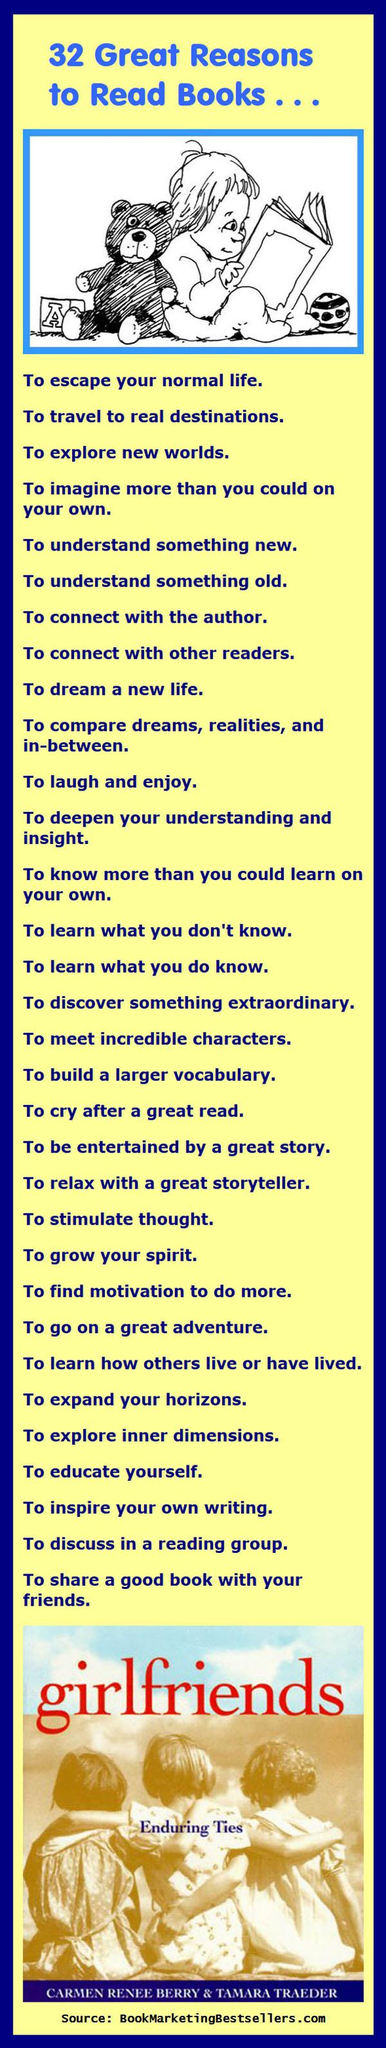Indicate a few pertinent items in this graphic. In the photograph, there are three girls depicted, and they are all shown to be in relationships with one another. 